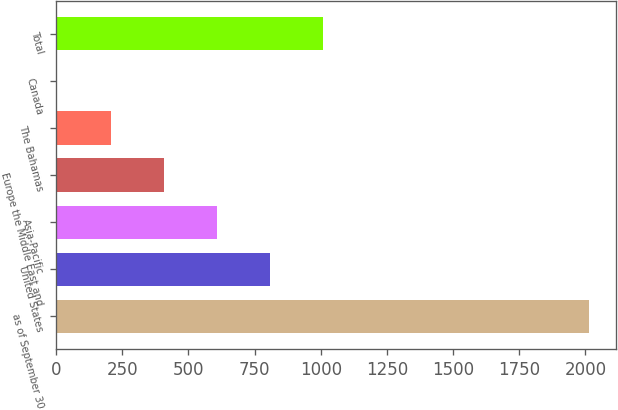<chart> <loc_0><loc_0><loc_500><loc_500><bar_chart><fcel>as of September 30<fcel>United States<fcel>Asia-Pacific<fcel>Europe the Middle East and<fcel>The Bahamas<fcel>Canada<fcel>Total<nl><fcel>2015<fcel>808.7<fcel>607.65<fcel>406.6<fcel>205.55<fcel>4.5<fcel>1009.75<nl></chart> 